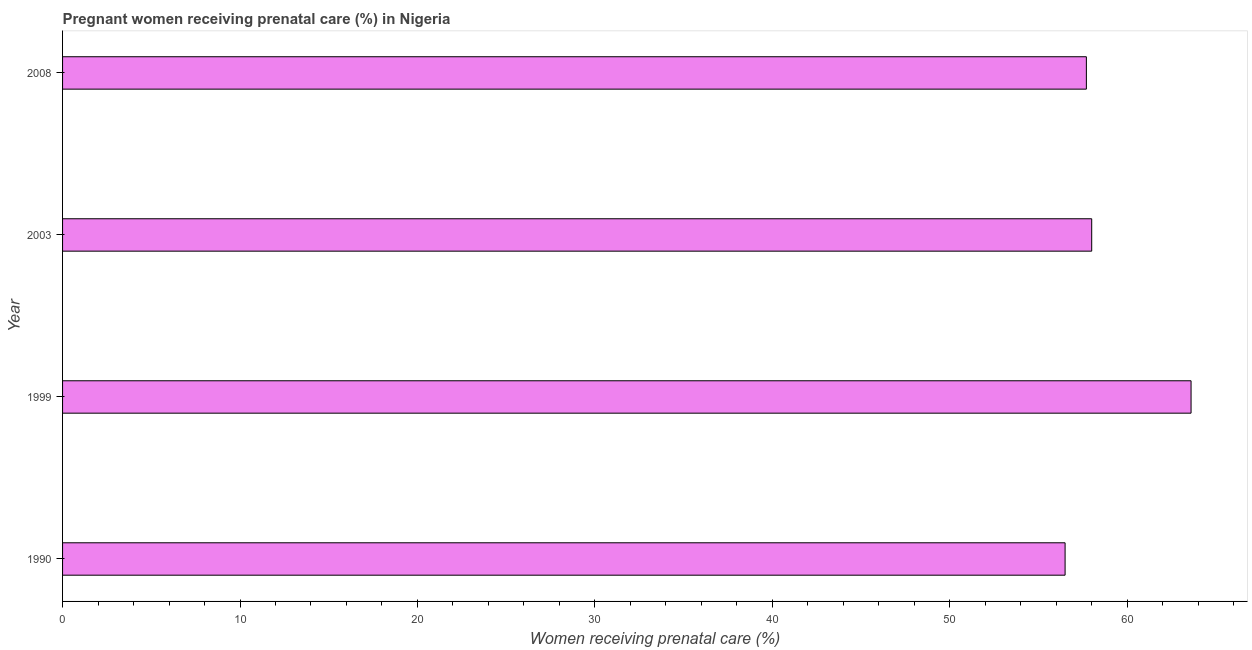What is the title of the graph?
Your answer should be compact. Pregnant women receiving prenatal care (%) in Nigeria. What is the label or title of the X-axis?
Offer a very short reply. Women receiving prenatal care (%). What is the percentage of pregnant women receiving prenatal care in 1990?
Your answer should be very brief. 56.5. Across all years, what is the maximum percentage of pregnant women receiving prenatal care?
Make the answer very short. 63.6. Across all years, what is the minimum percentage of pregnant women receiving prenatal care?
Offer a very short reply. 56.5. In which year was the percentage of pregnant women receiving prenatal care minimum?
Your answer should be very brief. 1990. What is the sum of the percentage of pregnant women receiving prenatal care?
Provide a short and direct response. 235.8. What is the difference between the percentage of pregnant women receiving prenatal care in 1999 and 2008?
Make the answer very short. 5.9. What is the average percentage of pregnant women receiving prenatal care per year?
Provide a short and direct response. 58.95. What is the median percentage of pregnant women receiving prenatal care?
Provide a succinct answer. 57.85. What is the ratio of the percentage of pregnant women receiving prenatal care in 1999 to that in 2003?
Ensure brevity in your answer.  1.1. What is the difference between the highest and the lowest percentage of pregnant women receiving prenatal care?
Offer a very short reply. 7.1. How many years are there in the graph?
Keep it short and to the point. 4. Are the values on the major ticks of X-axis written in scientific E-notation?
Provide a succinct answer. No. What is the Women receiving prenatal care (%) in 1990?
Offer a very short reply. 56.5. What is the Women receiving prenatal care (%) in 1999?
Your response must be concise. 63.6. What is the Women receiving prenatal care (%) in 2008?
Your answer should be very brief. 57.7. What is the difference between the Women receiving prenatal care (%) in 1990 and 2003?
Offer a very short reply. -1.5. What is the difference between the Women receiving prenatal care (%) in 1999 and 2003?
Your answer should be very brief. 5.6. What is the difference between the Women receiving prenatal care (%) in 1999 and 2008?
Your response must be concise. 5.9. What is the difference between the Women receiving prenatal care (%) in 2003 and 2008?
Your response must be concise. 0.3. What is the ratio of the Women receiving prenatal care (%) in 1990 to that in 1999?
Offer a very short reply. 0.89. What is the ratio of the Women receiving prenatal care (%) in 1999 to that in 2003?
Provide a short and direct response. 1.1. What is the ratio of the Women receiving prenatal care (%) in 1999 to that in 2008?
Provide a succinct answer. 1.1. What is the ratio of the Women receiving prenatal care (%) in 2003 to that in 2008?
Give a very brief answer. 1. 